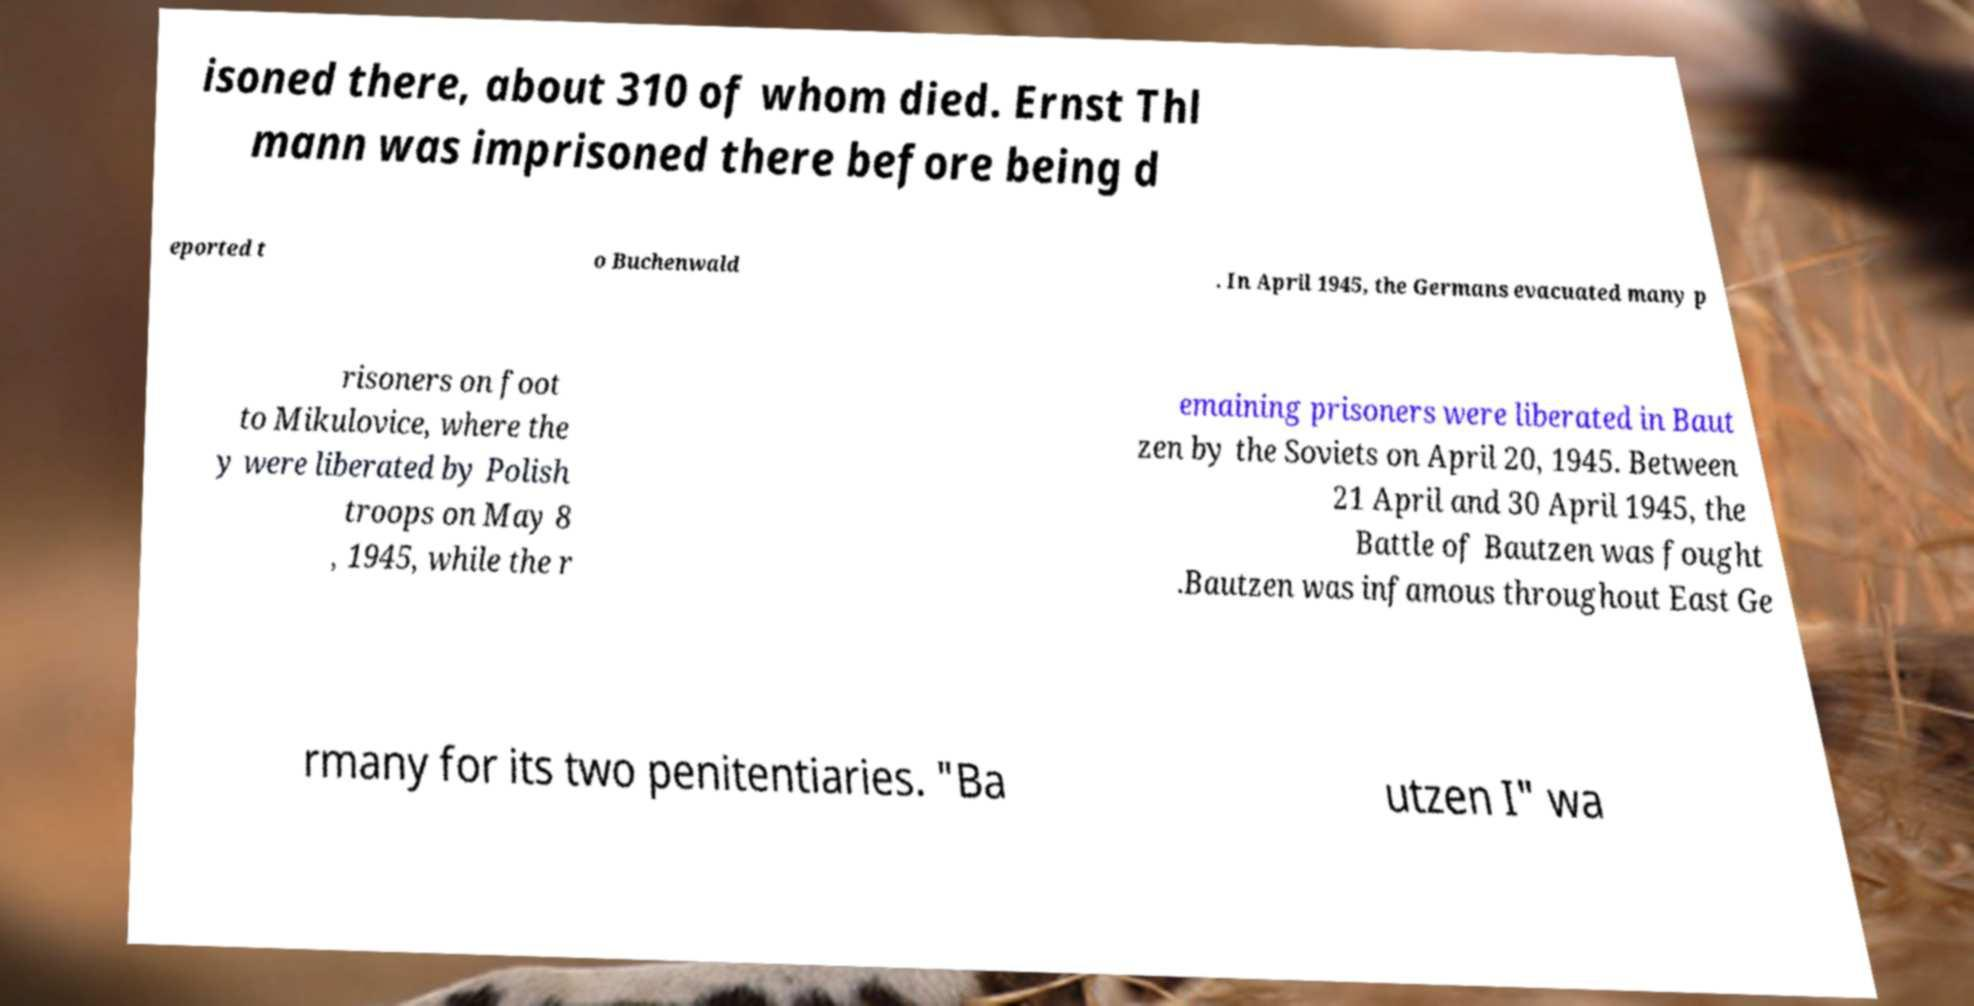Can you read and provide the text displayed in the image?This photo seems to have some interesting text. Can you extract and type it out for me? isoned there, about 310 of whom died. Ernst Thl mann was imprisoned there before being d eported t o Buchenwald . In April 1945, the Germans evacuated many p risoners on foot to Mikulovice, where the y were liberated by Polish troops on May 8 , 1945, while the r emaining prisoners were liberated in Baut zen by the Soviets on April 20, 1945. Between 21 April and 30 April 1945, the Battle of Bautzen was fought .Bautzen was infamous throughout East Ge rmany for its two penitentiaries. "Ba utzen I" wa 